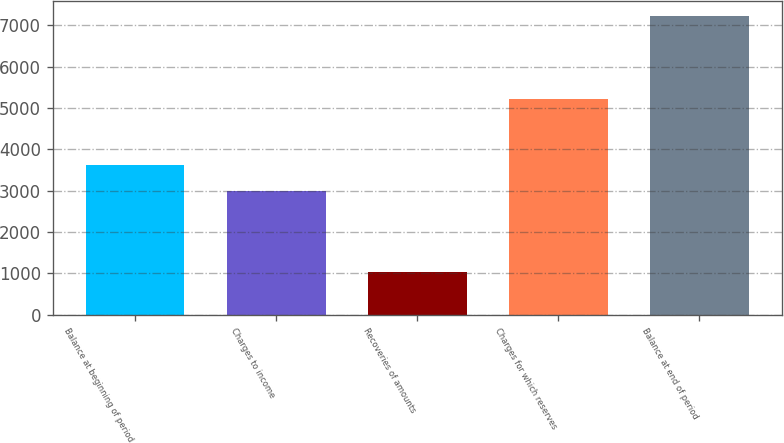Convert chart to OTSL. <chart><loc_0><loc_0><loc_500><loc_500><bar_chart><fcel>Balance at beginning of period<fcel>Charges to income<fcel>Recoveries of amounts<fcel>Charges for which reserves<fcel>Balance at end of period<nl><fcel>3618.8<fcel>2998<fcel>1026<fcel>5225<fcel>7234<nl></chart> 